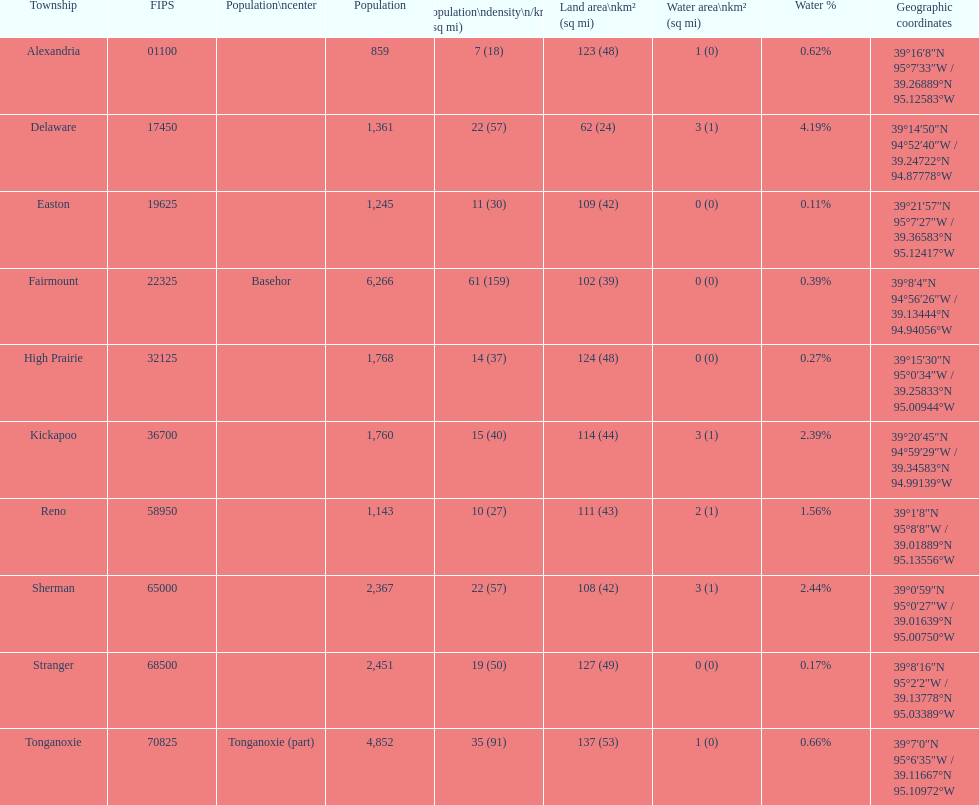Is the population of alexandria county greater or smaller than that of delaware county? Lower. 